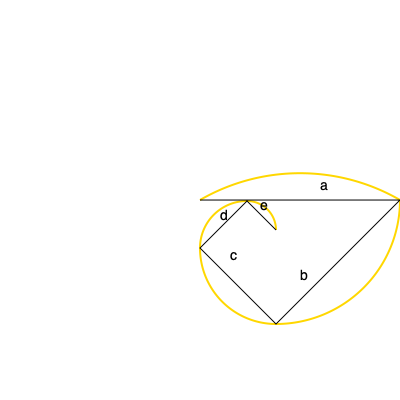In the golden spiral diagram above, which represents the golden ratio in nature and art, what is the relationship between consecutive segments (labeled a, b, c, d, e) of the spiral, and how does this relate to the Fibonacci sequence? To understand the relationship between consecutive segments in the golden spiral and the Fibonacci sequence:

1. The golden ratio, denoted by φ (phi), is approximately 1.618033988749895.

2. In a golden spiral, each segment's length is related to the previous one by the golden ratio. Mathematically, if we denote the length of a segment as L(n), then:

   $L(n) = φ * L(n-1)$

3. This means that:
   $\frac{a}{b} = \frac{b}{c} = \frac{c}{d} = \frac{d}{e} = φ$

4. The Fibonacci sequence (1, 1, 2, 3, 5, 8, 13, 21, ...) is closely related to the golden ratio. As the sequence progresses, the ratio between consecutive terms approaches φ:

   $\lim_{n \to \infty} \frac{F_{n+1}}{F_n} = φ$

5. In the spiral, if we approximate the lengths of the segments with Fibonacci numbers:
   a ≈ 13, b ≈ 8, c ≈ 5, d ≈ 3, e ≈ 2

6. The ratios between these consecutive Fibonacci numbers approximate φ:
   $\frac{13}{8} ≈ 1.625$
   $\frac{8}{5} = 1.6$
   $\frac{5}{3} ≈ 1.667$
   $\frac{3}{2} = 1.5$

These ratios converge to φ as we consider larger Fibonacci numbers.
Answer: Each segment is approximately 1.618 times longer than the next, mirroring the ratio of consecutive Fibonacci numbers. 